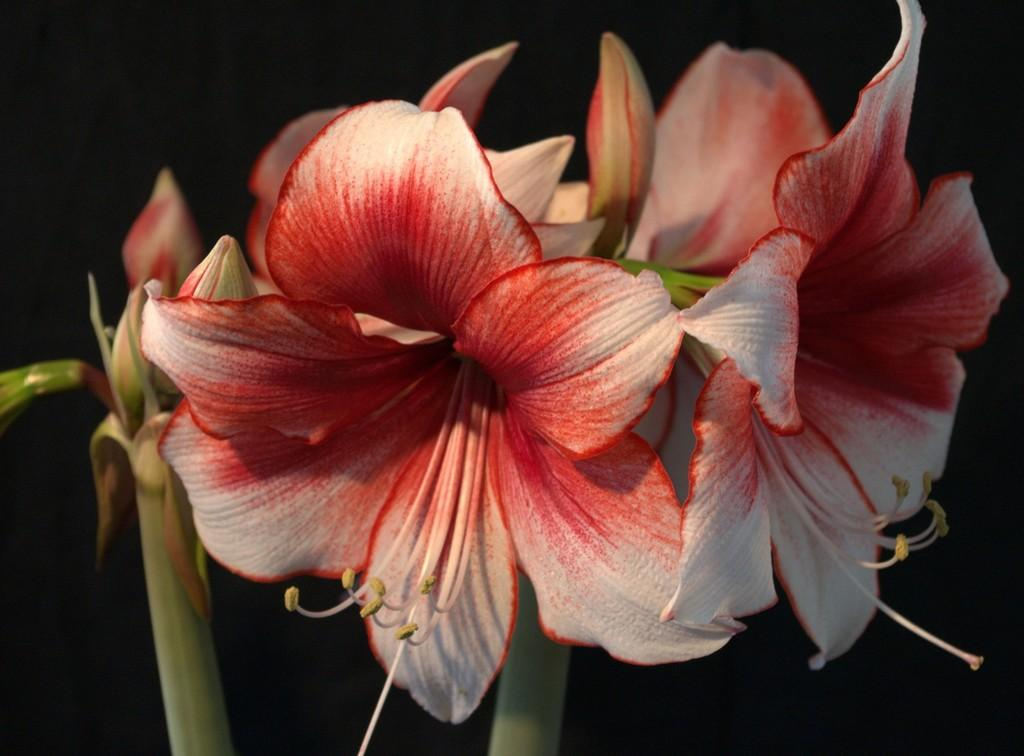What is the main subject in the center of the image? There are flowers and buds in the center of the image. What color is the background of the image? The background of the image is black. What type of spark can be seen in the wilderness in the image? There is no spark or wilderness present in the image; it features flowers and buds with a black background. 